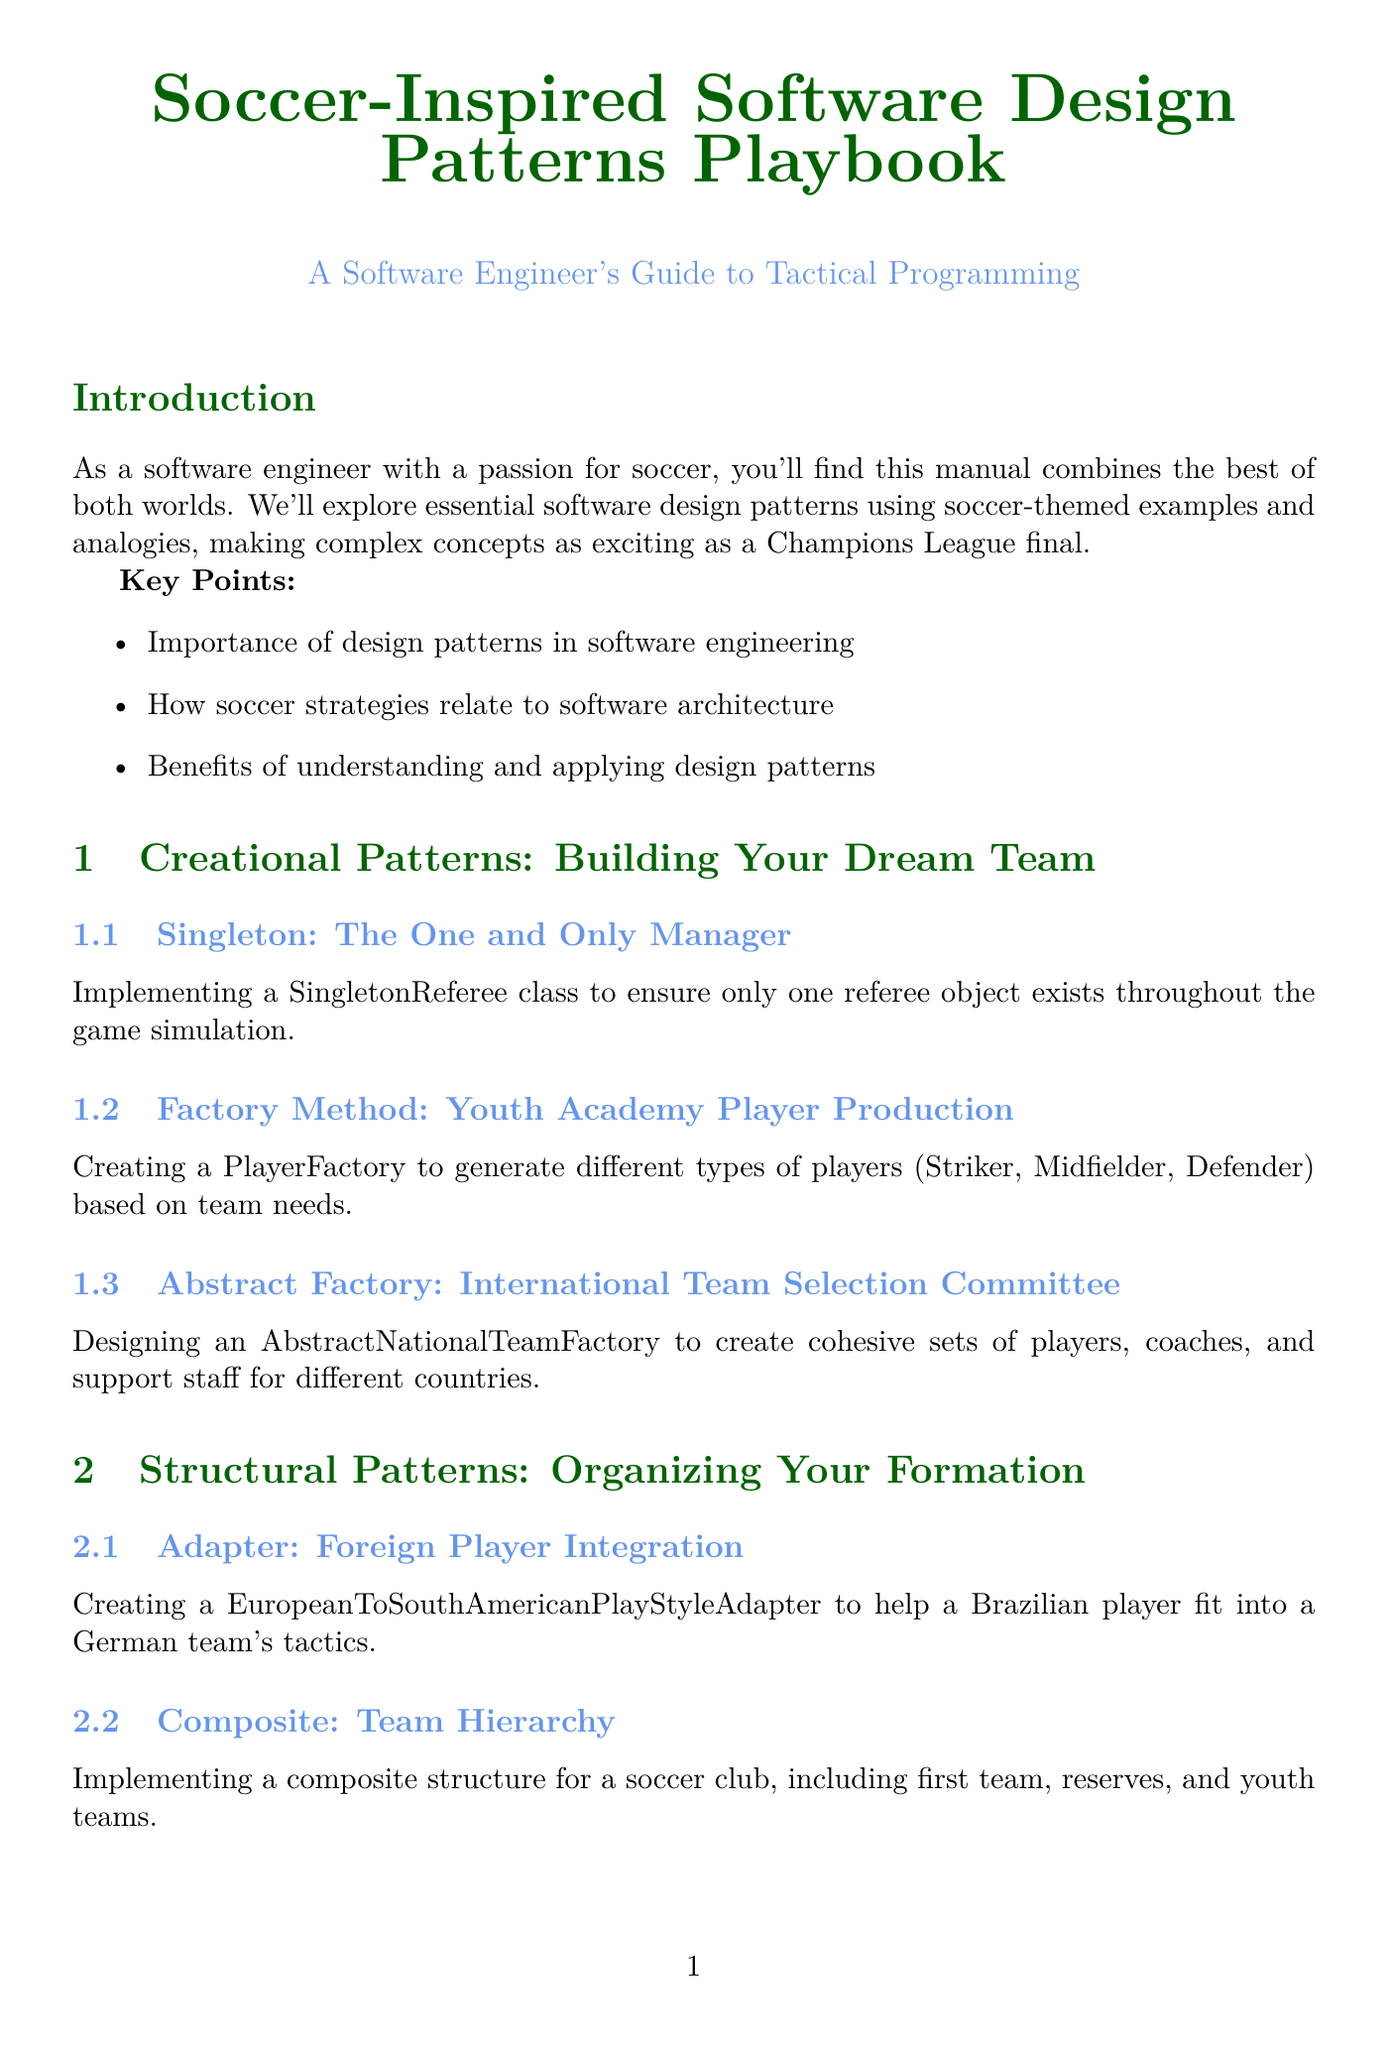what is the title of the manual? The title of the manual is clearly stated at the beginning of the document.
Answer: Soccer-Inspired Software Design Patterns Playbook what pattern is compared to the "One and Only Manager"? This is an Information Retrieval question looking for the design pattern mentioned in the document that relates to the soccer analogy.
Answer: Singleton which software design pattern is used for "Foreign Player Integration"? The question asks for the specific pattern associated with a soccer analogy depicted in the document.
Answer: Adapter how many chapters are in the manual? This requires counting the sections outlined in the document to determine the total number of chapters present.
Answer: 3 what is the example for the "Observer" pattern? This is a request for specific information regarding the implementation example provided in the manual.
Answer: Implementing an observer pattern for a VAR system that notifies the main referee of potential infractions which case study uses the "Decorator" pattern? This involves identifying which case study incorporates the mentioned design pattern discussed in the document.
Answer: Developing a Soccer Transfer Market Platform what is a key feature of the Soccer Team Management System case study? The question evaluates information retrieval regarding significant capabilities highlighted in one of the case studies.
Answer: Player database management who does the appendix compare to design patterns? This focuses on the specific individuals mentioned in the appendix of the document.
Answer: Famous Soccer Managers what is a next step suggested in the conclusion? This asks for an actionable item proposed at the end of the document that can direct readers toward further engagement.
Answer: Practice implementing these patterns in your own projects 